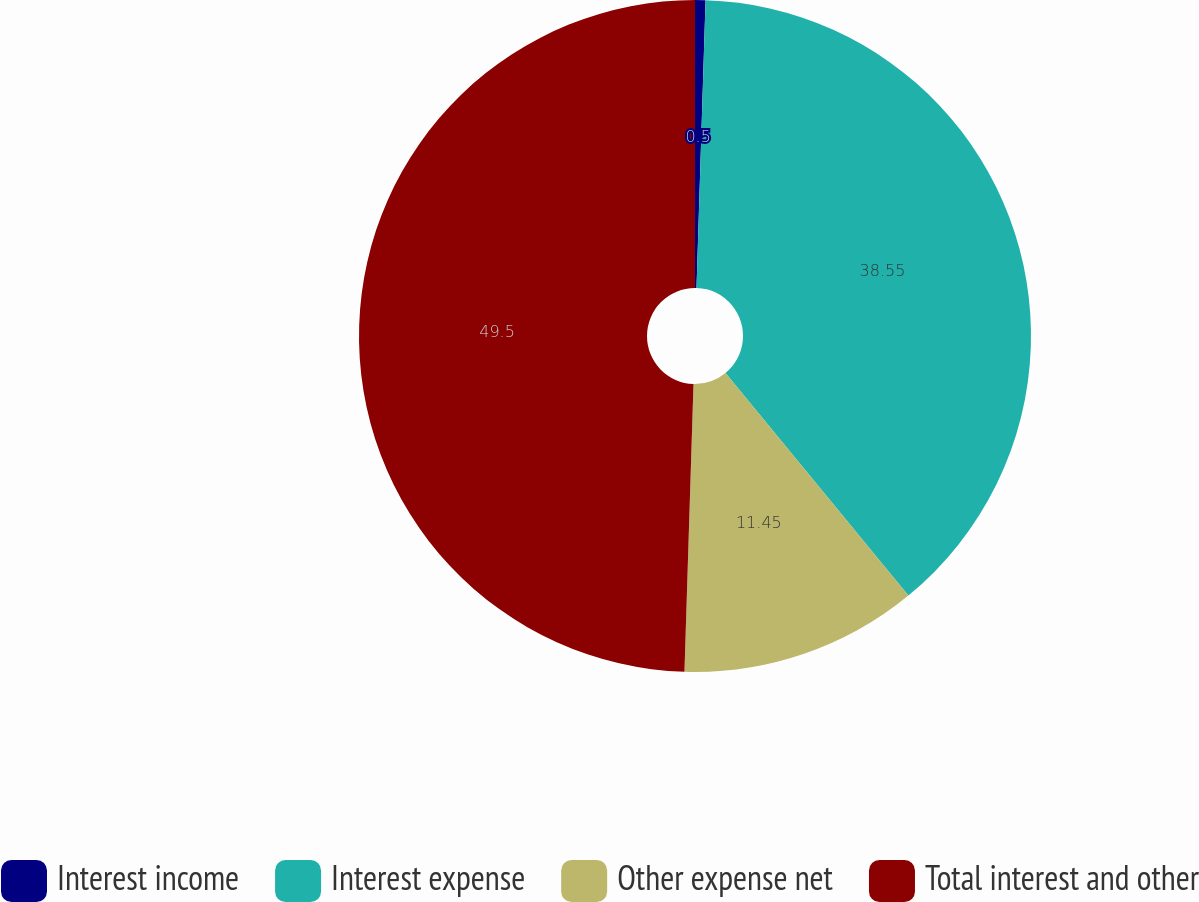Convert chart to OTSL. <chart><loc_0><loc_0><loc_500><loc_500><pie_chart><fcel>Interest income<fcel>Interest expense<fcel>Other expense net<fcel>Total interest and other<nl><fcel>0.5%<fcel>38.55%<fcel>11.45%<fcel>49.5%<nl></chart> 